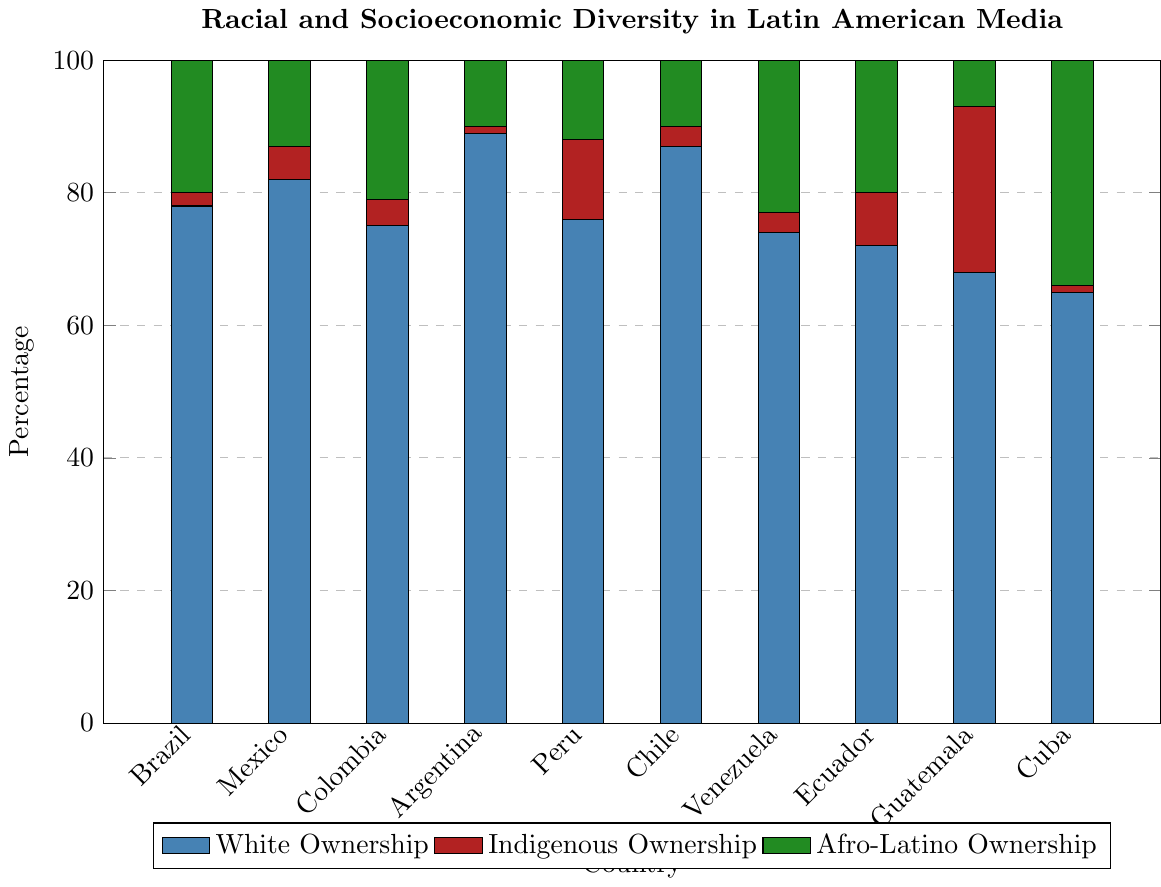What is the percentage range of Indigenous Ownership across all countries? First, identify the data points for Indigenous Ownership: 2%, 5%, 4%, 1%, 12%, 3%, 3%, 8%, 25%, 1%. The minimum value is 1%, and the maximum value is 25%.
Answer: 1%-25% Which country has the highest Afro-Latino Ownership? Observe the green bars representing Afro-Latino Ownership. The tallest green bar corresponds to Cuba with an Afro-Latino Ownership of 34%.
Answer: Cuba How does the percentage of White Ownership in Brazil compare to that in Argentina? Identify the blue bars for Brazil and Argentina: Brazil has 78% White Ownership, while Argentina has 89%. Argentina's White Ownership percentage is higher than Brazil's.
Answer: Argentina has higher What is the average percentage of Middle Class Executives across all countries? Sum the percentages of Middle Class Executives: 14%, 11%, 17%, 9%, 15%, 8%, 19%, 16%, 12%, 20%. The total is 141%, divided by 10 countries, resulting in an average of 14.1%.
Answer: 14.1% Which country has the least diverse media ownership based on Indigenous and Afro-Latino Ownership percentages? Look for the smallest combined percentages of Indigenous (red) and Afro-Latino (green) Ownership: Argentina has 1% Indigenous and 10% Afro-Latino, totaling 11%.
Answer: Argentina Compare the percentages of Upper Class Executives in Chile and Venezuela. Identify the respective bars: Chile has 91% Upper Class Executives, while Venezuela has 80%. Chile has a higher percentage of Upper Class Executives.
Answer: Chile has more Which countries have a working-class representation of executives at 1%? Observe the consistent value of the shortest bar for Working Class Executives: Brazil, Mexico, Colombia, Argentina, Peru, Chile, Venezuela, and Ecuador all have 1%.
Answer: Brazil, Mexico, Colombia, Argentina, Peru, Chile, Venezuela, Ecuador What is the difference in Afro-Latino Ownership between Ecuador and Brazil? Ecuador has 20% Afro-Latino Ownership (green), and Brazil has 20%. The difference is 0%.
Answer: 0% What is the total percentage of media ownership by Indigenous people in Guatemala and Peru combined? Sum the percentages for Indigenous Ownership: Guatemala (25%) and Peru (12%) total 37%.
Answer: 37% Which country exhibits the highest disparity between White and Afro-Latino Ownership percentages? Calculate the disparity for each country and identify the maximum: Argentina (89% White - 10% Afro-Latino) has the highest disparity of 79%.
Answer: Argentina 